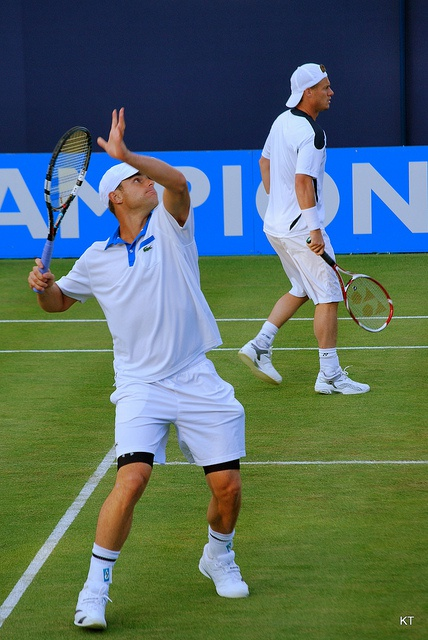Describe the objects in this image and their specific colors. I can see people in navy, darkgray, lavender, maroon, and brown tones, people in navy, lavender, and brown tones, tennis racket in navy, black, blue, and darkgray tones, and tennis racket in navy, olive, green, and maroon tones in this image. 